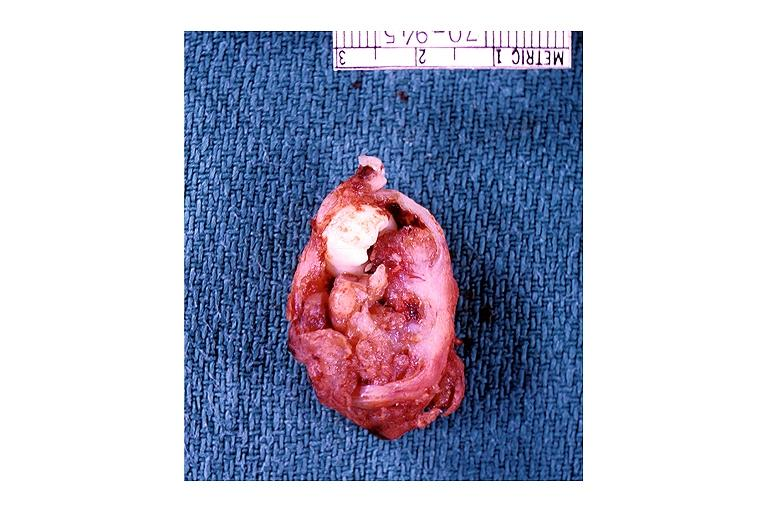where is this?
Answer the question using a single word or phrase. Oral 